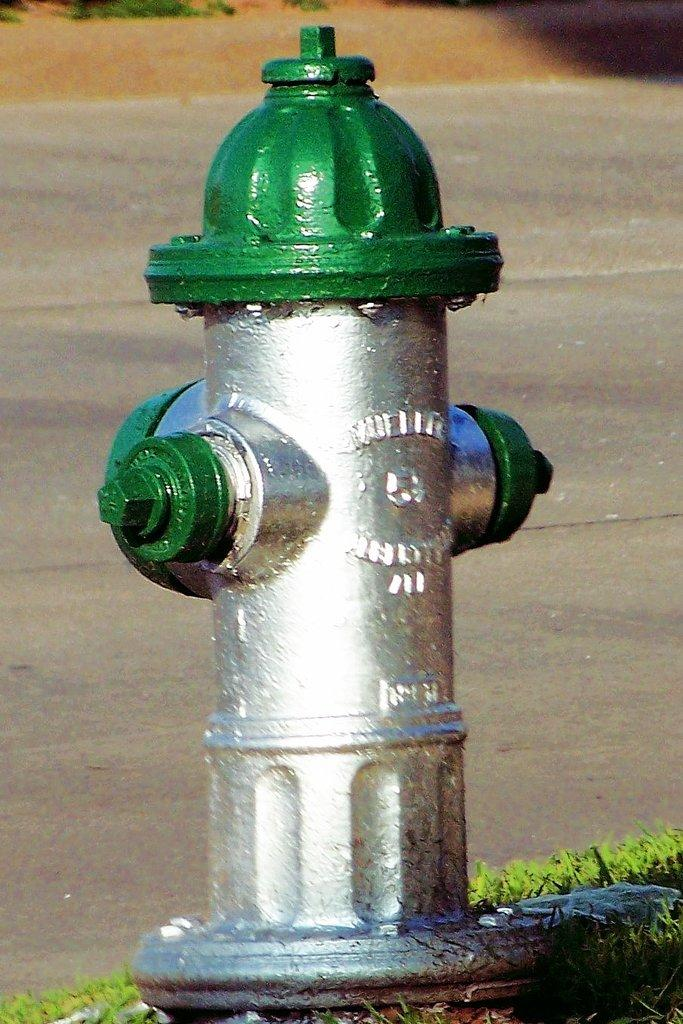What is the main object in the middle of the picture? There is a fire hydrant in the middle of the picture. What colors are used to paint the fire hydrant? The fire hydrant is in green and silver color. What can be seen in the background of the image? There is a road visible in the background of the image. What type of friction can be observed between the fire hydrant and the road in the image? There is no indication of friction between the fire hydrant and the road in the image. How does the fire hydrant make you feel when you look at the image? The image does not convey any emotions or feelings; it is simply a picture of a fire hydrant and a road. 